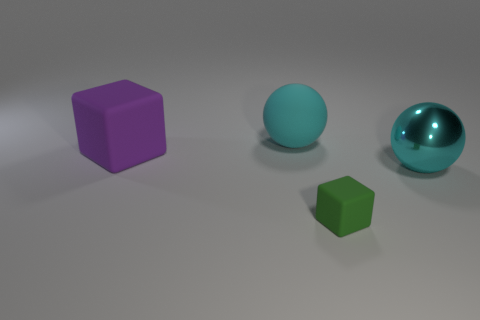Subtract 2 cubes. How many cubes are left? 0 Add 3 large metal spheres. How many objects exist? 7 Add 1 cyan rubber spheres. How many cyan rubber spheres are left? 2 Add 2 matte balls. How many matte balls exist? 3 Subtract 0 blue blocks. How many objects are left? 4 Subtract all large things. Subtract all cyan metal balls. How many objects are left? 0 